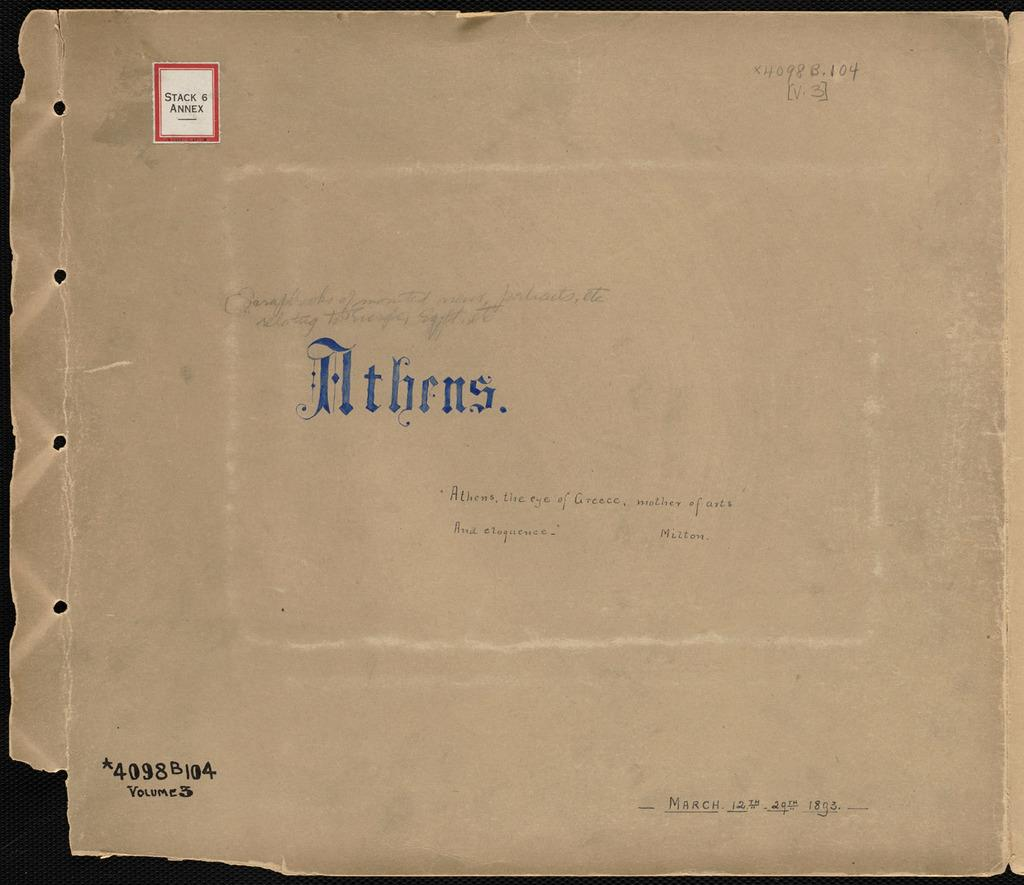<image>
Provide a brief description of the given image. A brown envelope containing Volume 3 of Athens, the eye of Greece, mother of arts and eloquence. 